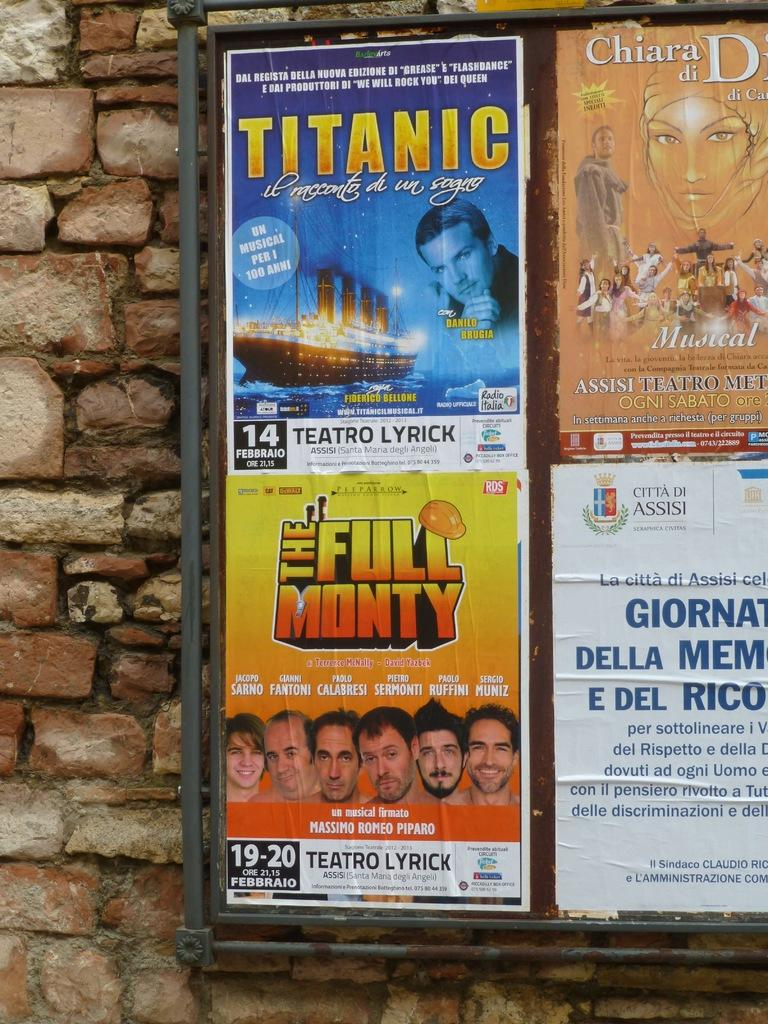What is on the wall in the image? There are posters on the wall in the image. What can be seen on the posters? The posters have text and images on them. Can you see any mines in the image? There are no mines present in the image. What type of fog can be seen in the image? There is no fog present in the image. 